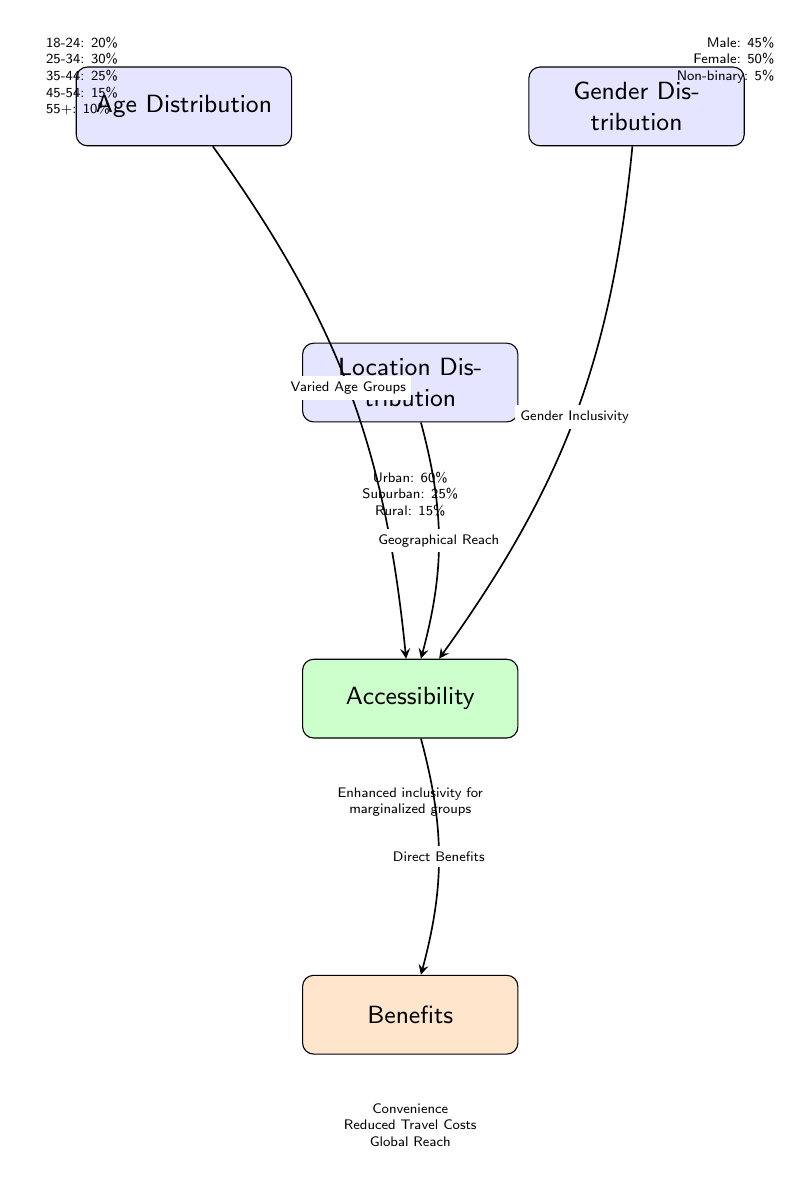What percentage of attendees are aged 25-34? The "Age Distribution" node shows that 25-34 age group constitutes 30% of attendees.
Answer: 30% What is the gender distribution percentage for non-binary attendees? The "Gender Distribution" node indicates that non-binary attendees make up 5%.
Answer: 5% How many distinct age groups are represented in the diagram? The "Age Distribution" node lists five age groups: 18-24, 25-34, 35-44, 45-54, and 55+.
Answer: 5 Which demographic has the highest percentage according to location distribution? The "Location Distribution" node indicates that urban attendees make up the highest percentage at 60%.
Answer: Urban What is the relationship between gender inclusivity and accessibility? The diagram shows an edge leading from the "Gender Distribution" node to the "Accessibility" node, indicating that gender inclusivity contributes to overall accessibility.
Answer: Gender Inclusivity What is the total percentage of attendees from rural locations? The "Location Distribution" node specifies that rural attendees account for 15% of the total.
Answer: 15% What benefits are listed directly beneath the Accessibility node? The "Benefits" node, which is linked from the "Accessibility" node, denotes three benefits: Convenience, Reduced Travel Costs, and Global Reach.
Answer: Convenience, Reduced Travel Costs, Global Reach How does varied age groups contribute to accessibility? The diagram shows an edge from the "Age Distribution" node to the "Accessibility" node, illustrating that varied age groups support increased accessibility.
Answer: Varied Age Groups What does the demographic distribution imply about the overall inclusivity of virtual town halls? The diagram suggests enhanced inclusivity for marginalized groups through the connections among demographics, making virtual town halls more accessible to diverse populations.
Answer: Enhanced inclusivity for marginalized groups 